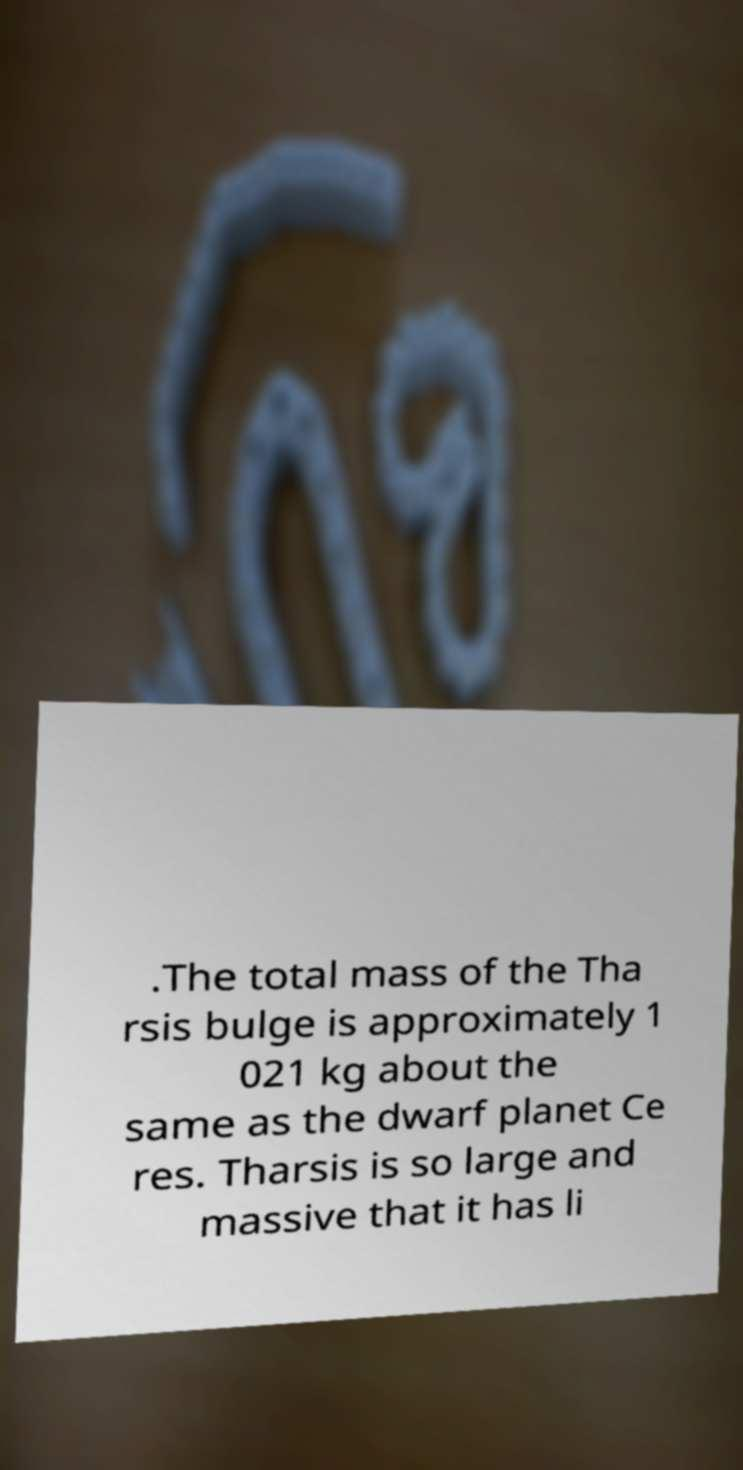Please read and relay the text visible in this image. What does it say? .The total mass of the Tha rsis bulge is approximately 1 021 kg about the same as the dwarf planet Ce res. Tharsis is so large and massive that it has li 